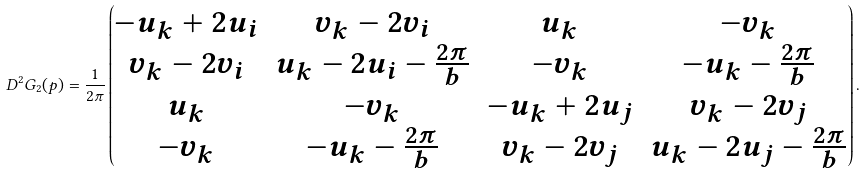Convert formula to latex. <formula><loc_0><loc_0><loc_500><loc_500>D ^ { 2 } G _ { 2 } ( p ) = \frac { 1 } { 2 \pi } \begin{pmatrix} - u _ { k } + 2 u _ { i } & v _ { k } - 2 v _ { i } & u _ { k } & - v _ { k } \\ v _ { k } - 2 v _ { i } & u _ { k } - 2 u _ { i } - \frac { 2 \pi } { b } & - v _ { k } & - u _ { k } - \frac { 2 \pi } { b } \\ u _ { k } & - v _ { k } & - u _ { k } + 2 u _ { j } & v _ { k } - 2 v _ { j } \\ - v _ { k } & - u _ { k } - \frac { 2 \pi } { b } & v _ { k } - 2 v _ { j } & u _ { k } - 2 u _ { j } - \frac { 2 \pi } { b } \end{pmatrix} .</formula> 